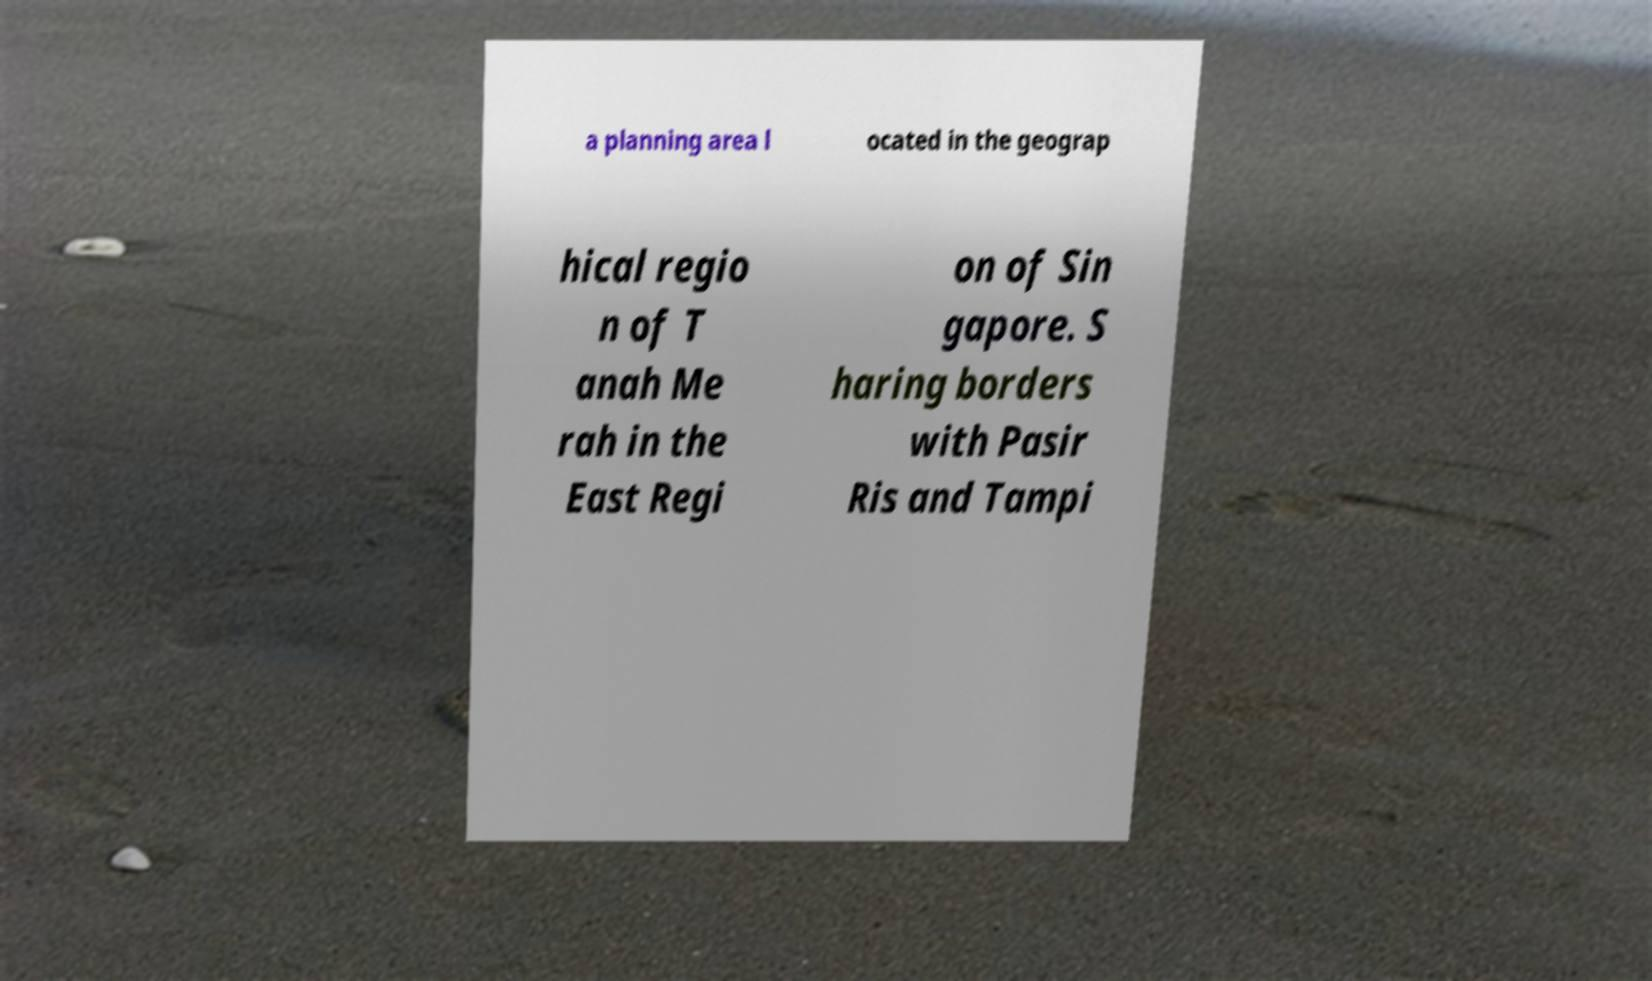Can you accurately transcribe the text from the provided image for me? a planning area l ocated in the geograp hical regio n of T anah Me rah in the East Regi on of Sin gapore. S haring borders with Pasir Ris and Tampi 